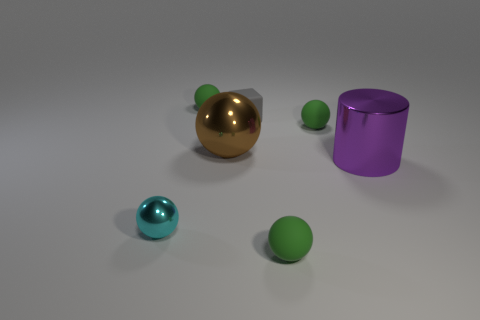Does the brown metallic object have the same size as the cyan sphere?
Your answer should be compact. No. How many objects are either green matte spheres that are in front of the cyan thing or matte objects?
Ensure brevity in your answer.  4. What size is the metal sphere in front of the large purple shiny object?
Your answer should be compact. Small. There is a purple thing; is its size the same as the green rubber ball in front of the brown shiny thing?
Provide a succinct answer. No. There is a shiny ball on the left side of the green matte sphere to the left of the rubber cube; what is its color?
Give a very brief answer. Cyan. How many other things are the same color as the tiny rubber cube?
Provide a succinct answer. 0. The cyan shiny sphere has what size?
Offer a terse response. Small. Is the number of small green rubber balls to the right of the big sphere greater than the number of brown metallic things on the left side of the rubber block?
Give a very brief answer. Yes. What number of cylinders are behind the green sphere left of the big brown metallic object?
Make the answer very short. 0. There is a green matte object in front of the cyan thing; is its shape the same as the small cyan shiny object?
Offer a very short reply. Yes. 